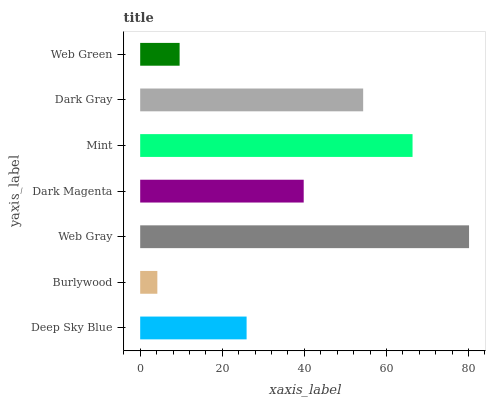Is Burlywood the minimum?
Answer yes or no. Yes. Is Web Gray the maximum?
Answer yes or no. Yes. Is Web Gray the minimum?
Answer yes or no. No. Is Burlywood the maximum?
Answer yes or no. No. Is Web Gray greater than Burlywood?
Answer yes or no. Yes. Is Burlywood less than Web Gray?
Answer yes or no. Yes. Is Burlywood greater than Web Gray?
Answer yes or no. No. Is Web Gray less than Burlywood?
Answer yes or no. No. Is Dark Magenta the high median?
Answer yes or no. Yes. Is Dark Magenta the low median?
Answer yes or no. Yes. Is Mint the high median?
Answer yes or no. No. Is Web Gray the low median?
Answer yes or no. No. 